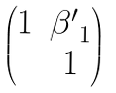<formula> <loc_0><loc_0><loc_500><loc_500>\begin{pmatrix} 1 & { \beta ^ { \prime } } _ { 1 } \\ & 1 \end{pmatrix}</formula> 